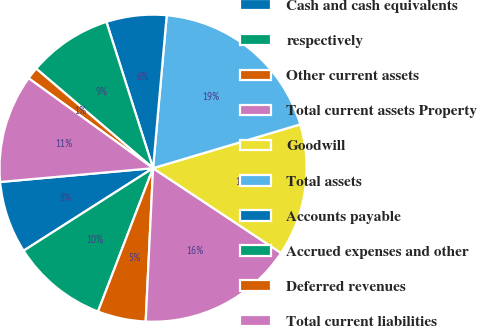<chart> <loc_0><loc_0><loc_500><loc_500><pie_chart><fcel>Cash and cash equivalents<fcel>respectively<fcel>Other current assets<fcel>Total current assets Property<fcel>Goodwill<fcel>Total assets<fcel>Accounts payable<fcel>Accrued expenses and other<fcel>Deferred revenues<fcel>Total current liabilities<nl><fcel>7.6%<fcel>10.13%<fcel>5.07%<fcel>16.45%<fcel>13.92%<fcel>18.98%<fcel>6.33%<fcel>8.86%<fcel>1.27%<fcel>11.39%<nl></chart> 